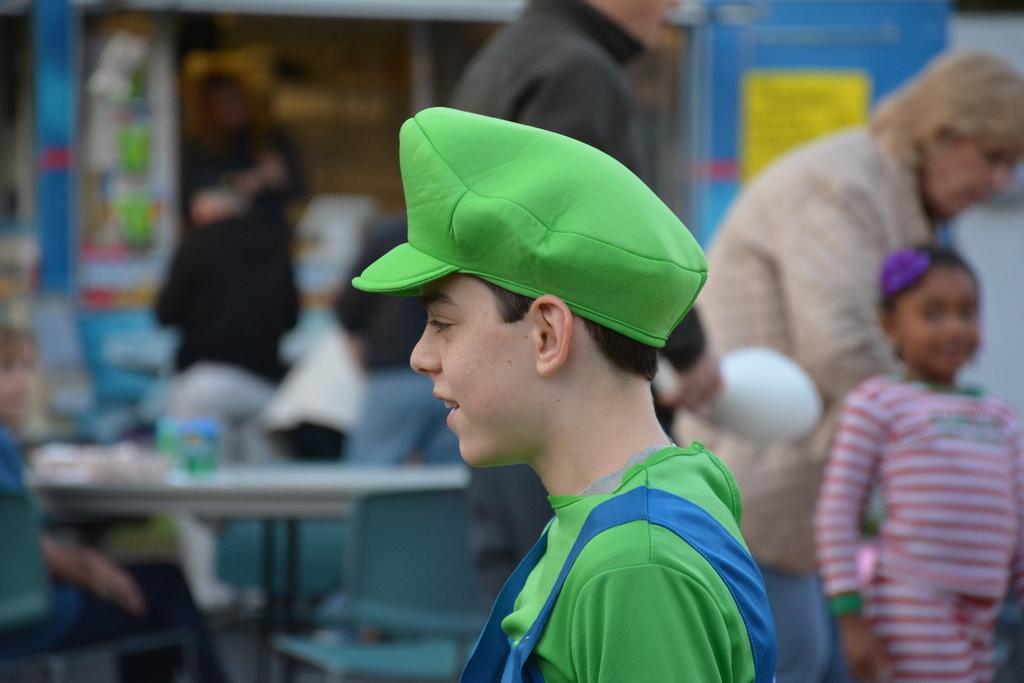How would you summarize this image in a sentence or two? In this image, there are a few people. We can also see a person wearing a cap. In the background, we can see the store and a yellow colored object. 